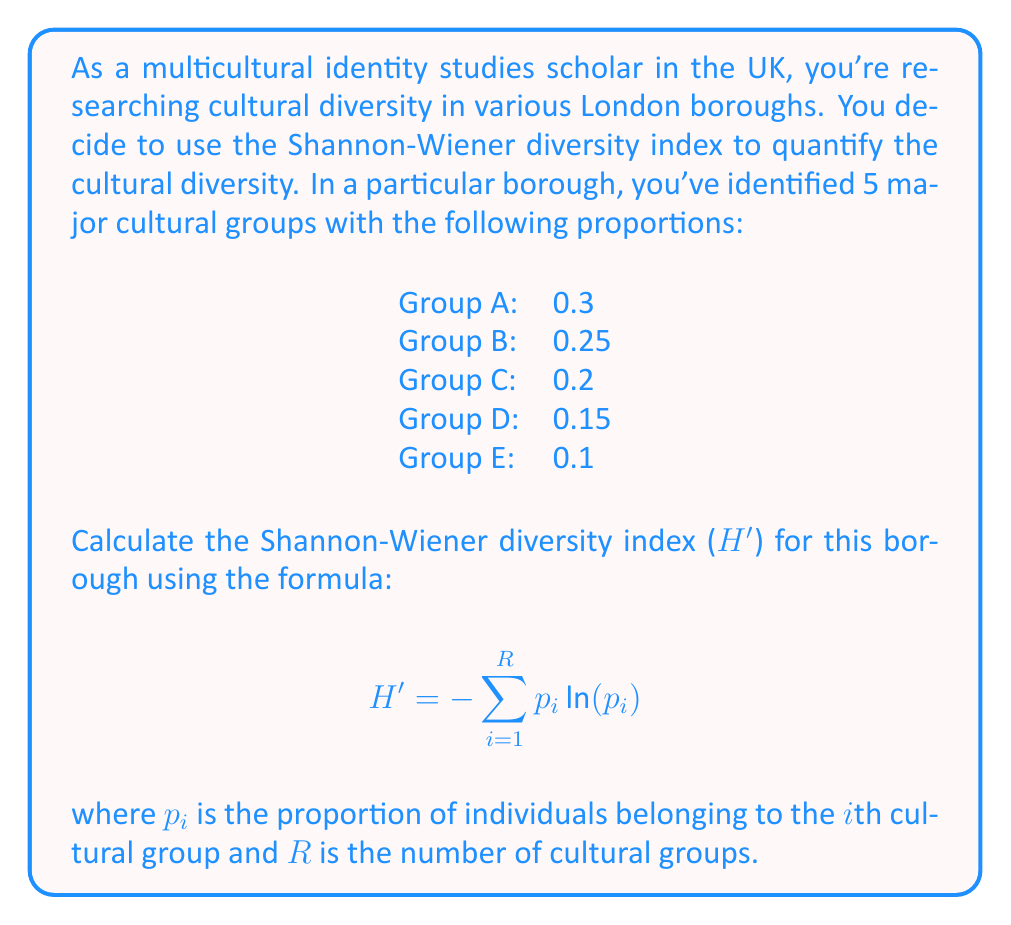Provide a solution to this math problem. To calculate the Shannon-Wiener diversity index, we need to follow these steps:

1. For each cultural group, calculate $p_i \ln(p_i)$:

   Group A: $0.3 \ln(0.3) = 0.3 \times (-1.2040) = -0.3612$
   Group B: $0.25 \ln(0.25) = 0.25 \times (-1.3863) = -0.3466$
   Group C: $0.2 \ln(0.2) = 0.2 \times (-1.6094) = -0.3219$
   Group D: $0.15 \ln(0.15) = 0.15 \times (-1.8971) = -0.2846$
   Group E: $0.1 \ln(0.1) = 0.1 \times (-2.3026) = -0.2303$

2. Sum up all these values:

   $\sum_{i=1}^{R} p_i \ln(p_i) = (-0.3612) + (-0.3466) + (-0.3219) + (-0.2846) + (-0.2303) = -1.5446$

3. Multiply the sum by -1 to get the final Shannon-Wiener diversity index:

   $H' = -(-1.5446) = 1.5446$

The Shannon-Wiener diversity index ranges from 0 (only one species) to $\ln(R)$ (all species are equally abundant). In this case, the maximum possible value would be $\ln(5) \approx 1.6094$. Our calculated value of 1.5446 indicates a high level of cultural diversity in this borough.
Answer: $H' = 1.5446$ 